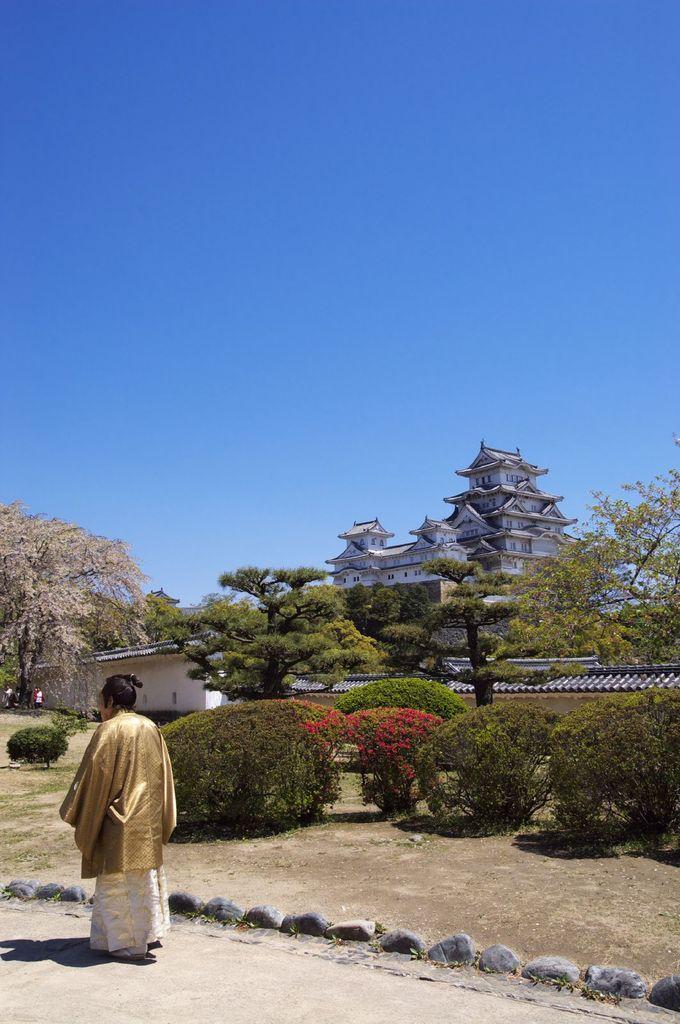In one or two sentences, can you explain what this image depicts? In this image we can see a person standing on the left side of the image and there are some plants and trees and and we can see the castle in the background and at the top we can see the sky. 